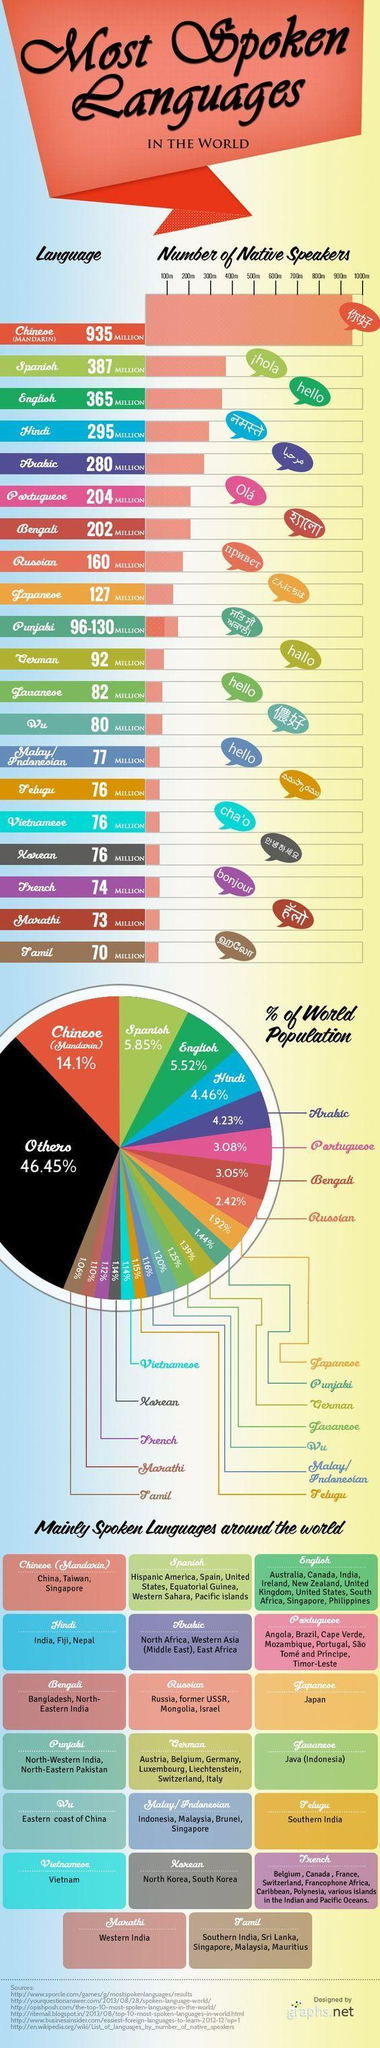which are the countries with Tamil speaking population other than India or Sri Lanka according to this infographic?
Answer the question with a short phrase. Singapore, Malaysia, Mauritius What is the fourth most spoken language in the world? Hindi Among these languages, how many are spoken in India? 7 what percent of world population speak Japanese? 1.92 which are the countries with Chinese speaking population other than China according to this infographic? Taiwan, Singapore which are the countries with Hindi speaking population other than India according to this infographic? Fiji, Nepal What is the third most spoken language in the world? English What is the second most spoken language in the world? Spanish which is the most spoken language after Arabic Portuguese? Bengali what is the percentage of world population who speak Hindi or English? 9.98 What is the fifth most spoken language in the world? Arabic which is the most spoken language after Arabic? Portuguese what is the percentage of world population who speak Spanish or English? 11.37 what is the percentage of world population who speak Hindi or Arabic? 8.69% which are the languages spoken by more than 500 million people? Chinese 